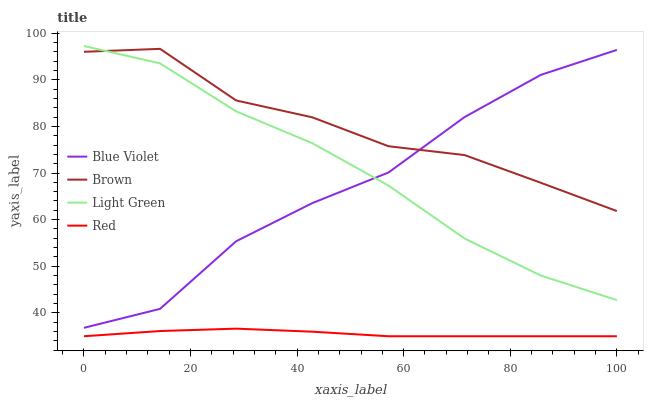Does Light Green have the minimum area under the curve?
Answer yes or no. No. Does Light Green have the maximum area under the curve?
Answer yes or no. No. Is Light Green the smoothest?
Answer yes or no. No. Is Light Green the roughest?
Answer yes or no. No. Does Light Green have the lowest value?
Answer yes or no. No. Does Red have the highest value?
Answer yes or no. No. Is Red less than Blue Violet?
Answer yes or no. Yes. Is Blue Violet greater than Red?
Answer yes or no. Yes. Does Red intersect Blue Violet?
Answer yes or no. No. 